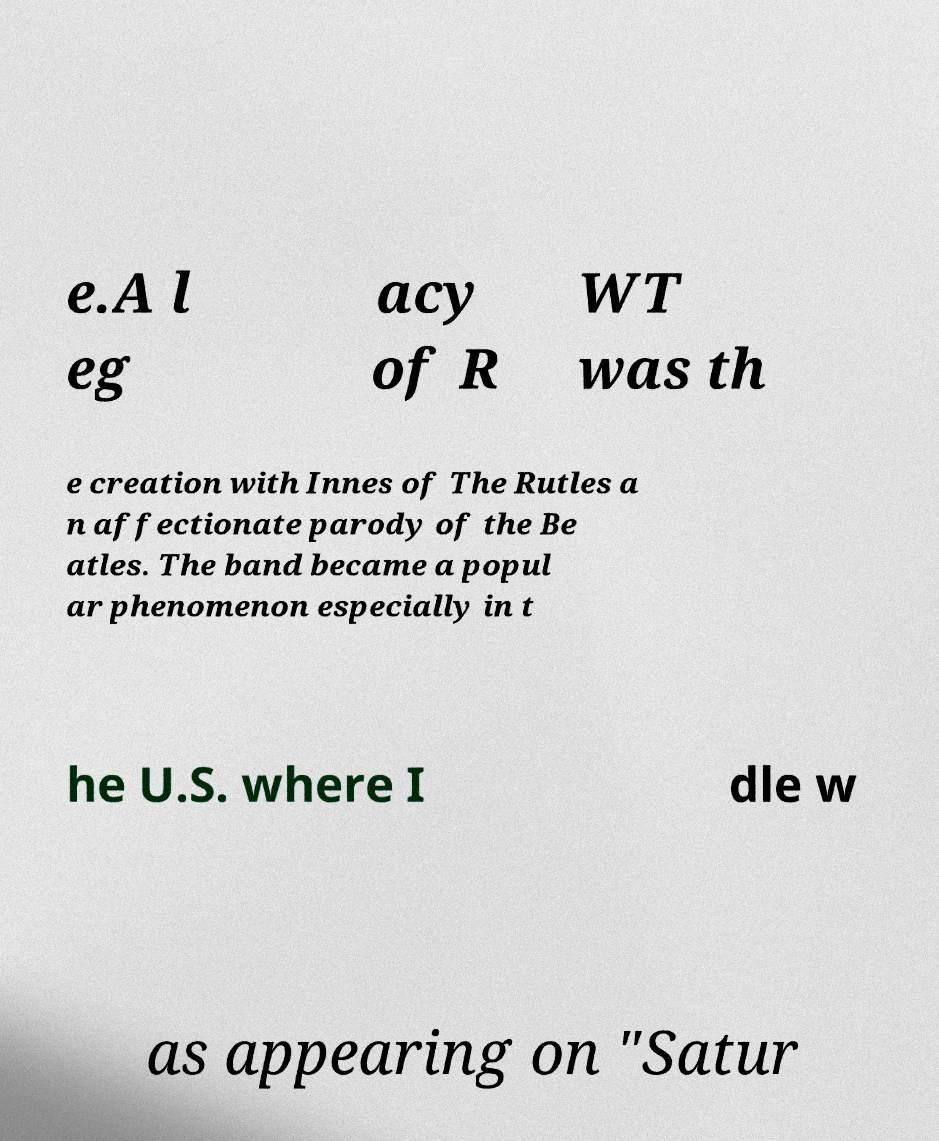There's text embedded in this image that I need extracted. Can you transcribe it verbatim? e.A l eg acy of R WT was th e creation with Innes of The Rutles a n affectionate parody of the Be atles. The band became a popul ar phenomenon especially in t he U.S. where I dle w as appearing on "Satur 